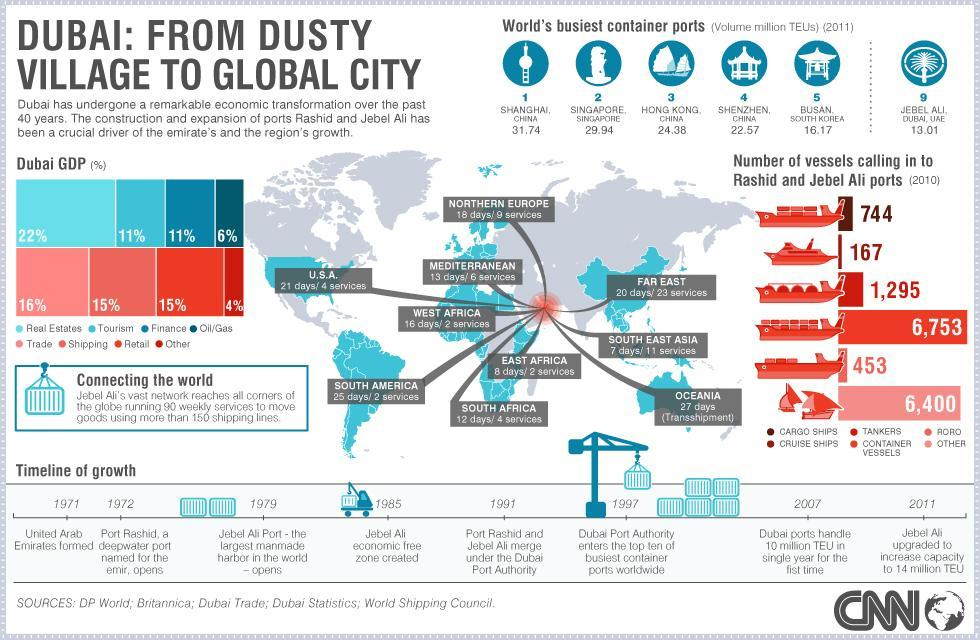Which type of vessel makes the third lowest calls to the Dubai ports?
Answer the question with a short phrase. Cargo ships What is the total number of Roro and container vessels that call into the ports of Dubai? 1748 What is second highest contributor of Dubai GDP? Trade How many regions does the Jebel Ali port connect to? 10 What is percentage difference in contribution of GDP in between real estate and shipping? 7% When was the merger of the two ports in Dubai? 1991 